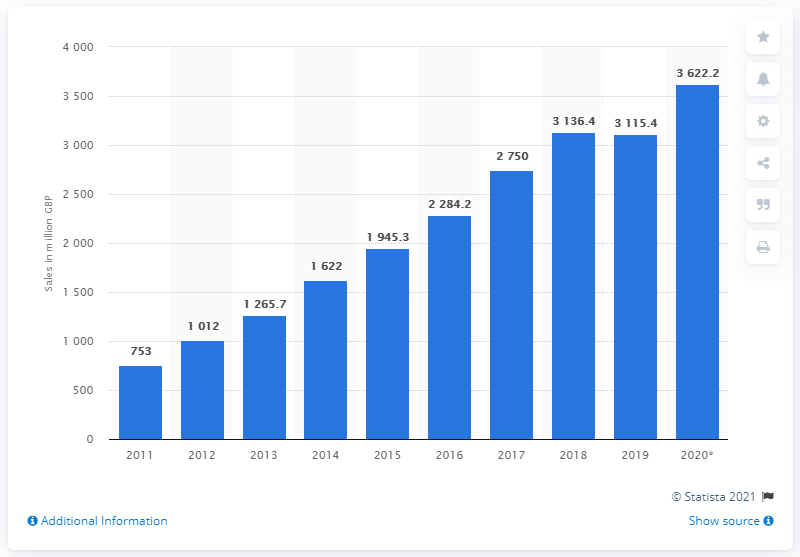Identify some key points in this picture. In 2020, a total of £3622.2 million was spent on digital video games in the United Kingdom. 